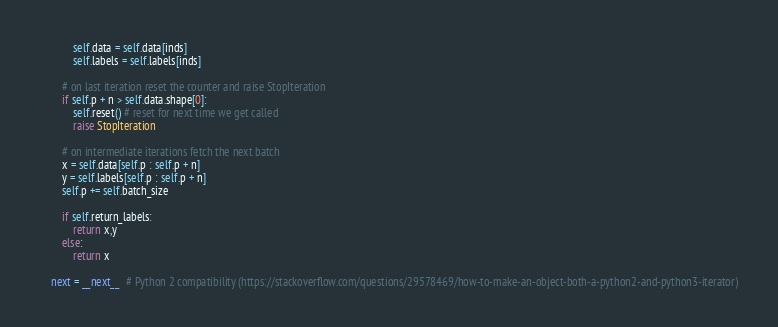<code> <loc_0><loc_0><loc_500><loc_500><_Python_>            self.data = self.data[inds]
            self.labels = self.labels[inds]

        # on last iteration reset the counter and raise StopIteration
        if self.p + n > self.data.shape[0]:
            self.reset() # reset for next time we get called
            raise StopIteration

        # on intermediate iterations fetch the next batch
        x = self.data[self.p : self.p + n]
        y = self.labels[self.p : self.p + n]
        self.p += self.batch_size

        if self.return_labels:
            return x,y
        else:
            return x

    next = __next__  # Python 2 compatibility (https://stackoverflow.com/questions/29578469/how-to-make-an-object-both-a-python2-and-python3-iterator)
</code> 